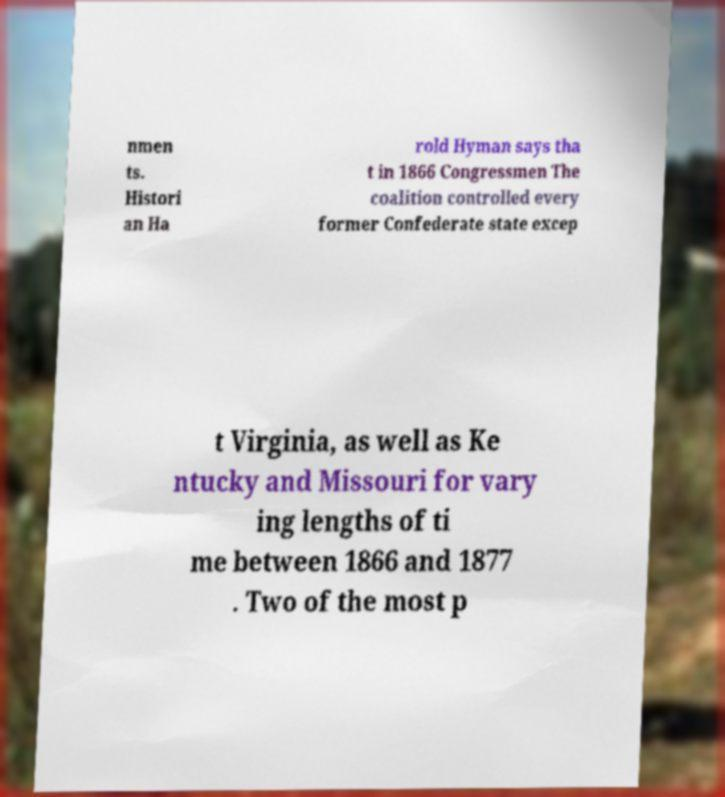I need the written content from this picture converted into text. Can you do that? nmen ts. Histori an Ha rold Hyman says tha t in 1866 Congressmen The coalition controlled every former Confederate state excep t Virginia, as well as Ke ntucky and Missouri for vary ing lengths of ti me between 1866 and 1877 . Two of the most p 